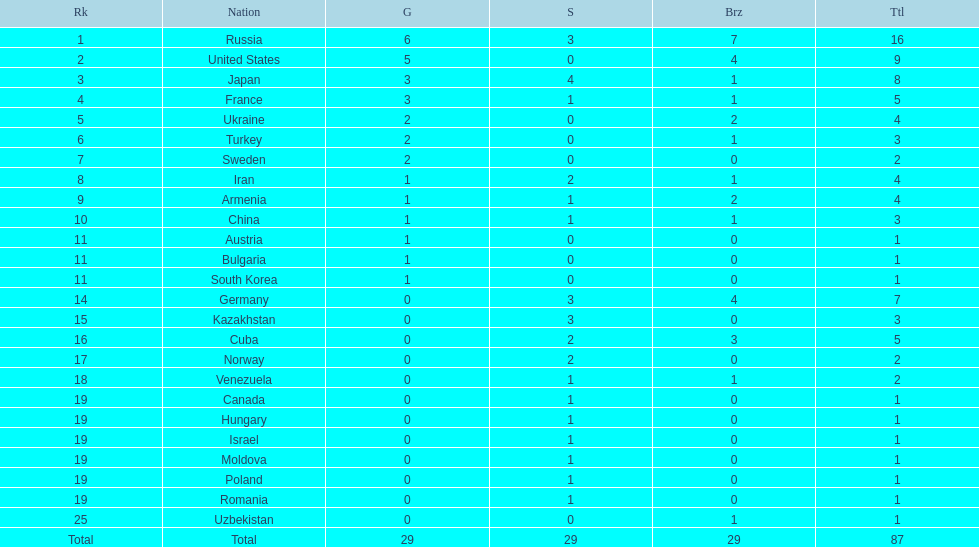Which country had the highest number of medals? Russia. 